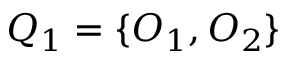<formula> <loc_0><loc_0><loc_500><loc_500>Q _ { 1 } = \{ O _ { 1 } , O _ { 2 } \}</formula> 